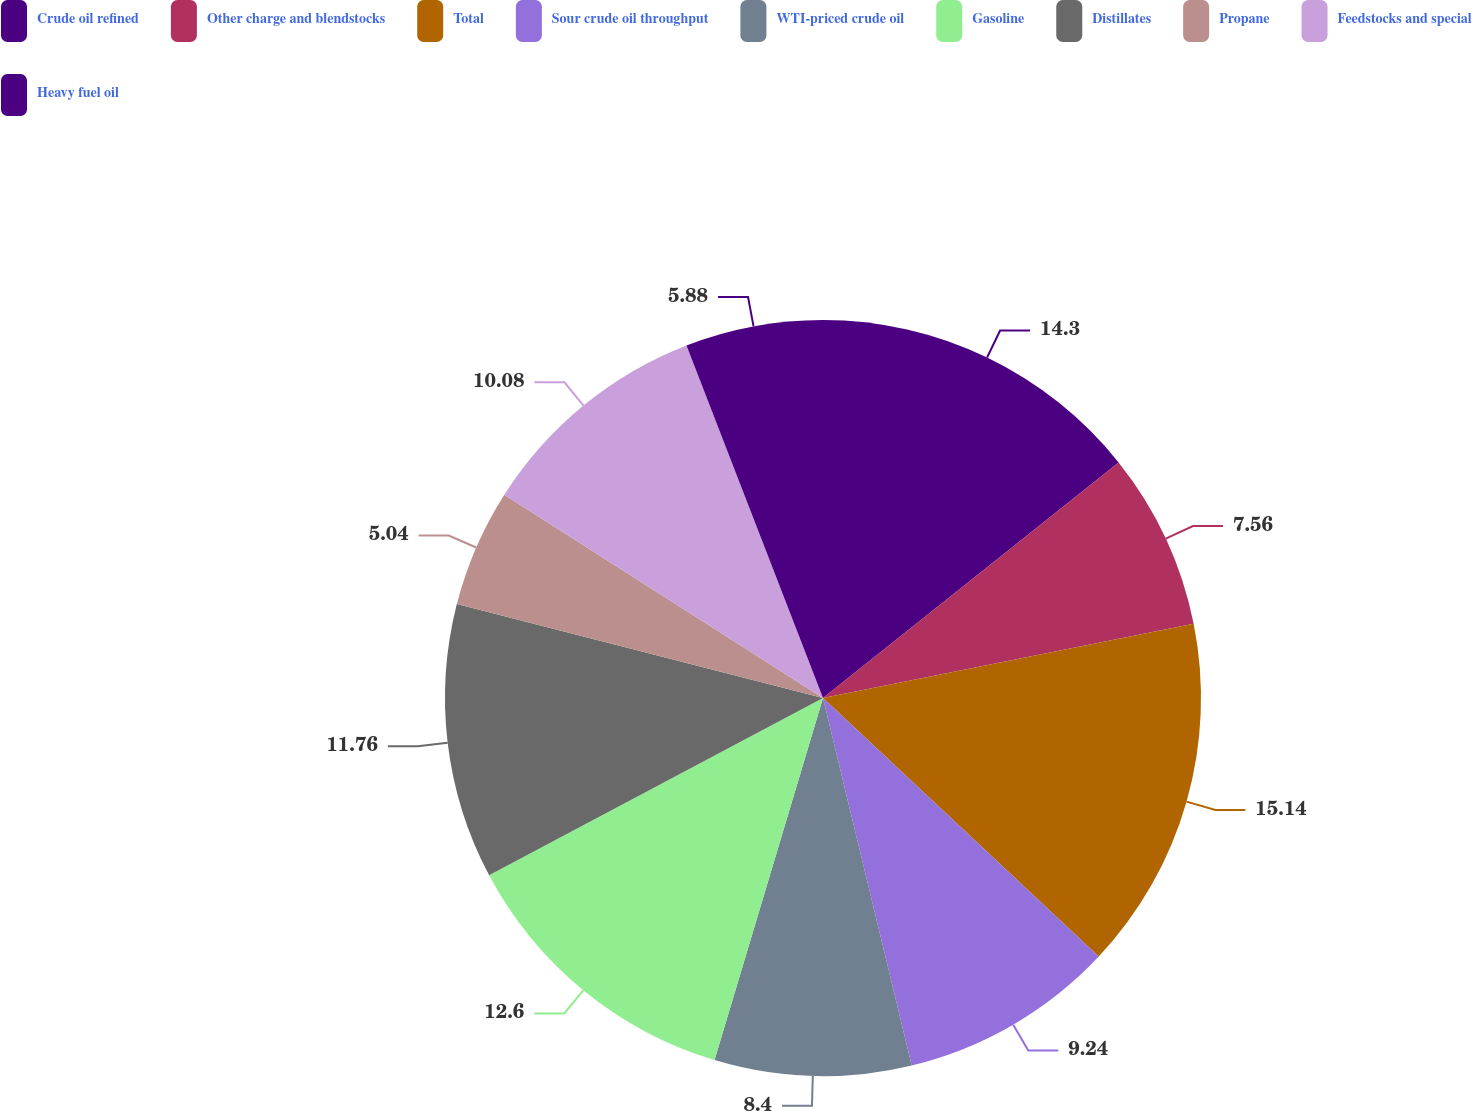Convert chart. <chart><loc_0><loc_0><loc_500><loc_500><pie_chart><fcel>Crude oil refined<fcel>Other charge and blendstocks<fcel>Total<fcel>Sour crude oil throughput<fcel>WTI-priced crude oil<fcel>Gasoline<fcel>Distillates<fcel>Propane<fcel>Feedstocks and special<fcel>Heavy fuel oil<nl><fcel>14.29%<fcel>7.56%<fcel>15.13%<fcel>9.24%<fcel>8.4%<fcel>12.6%<fcel>11.76%<fcel>5.04%<fcel>10.08%<fcel>5.88%<nl></chart> 